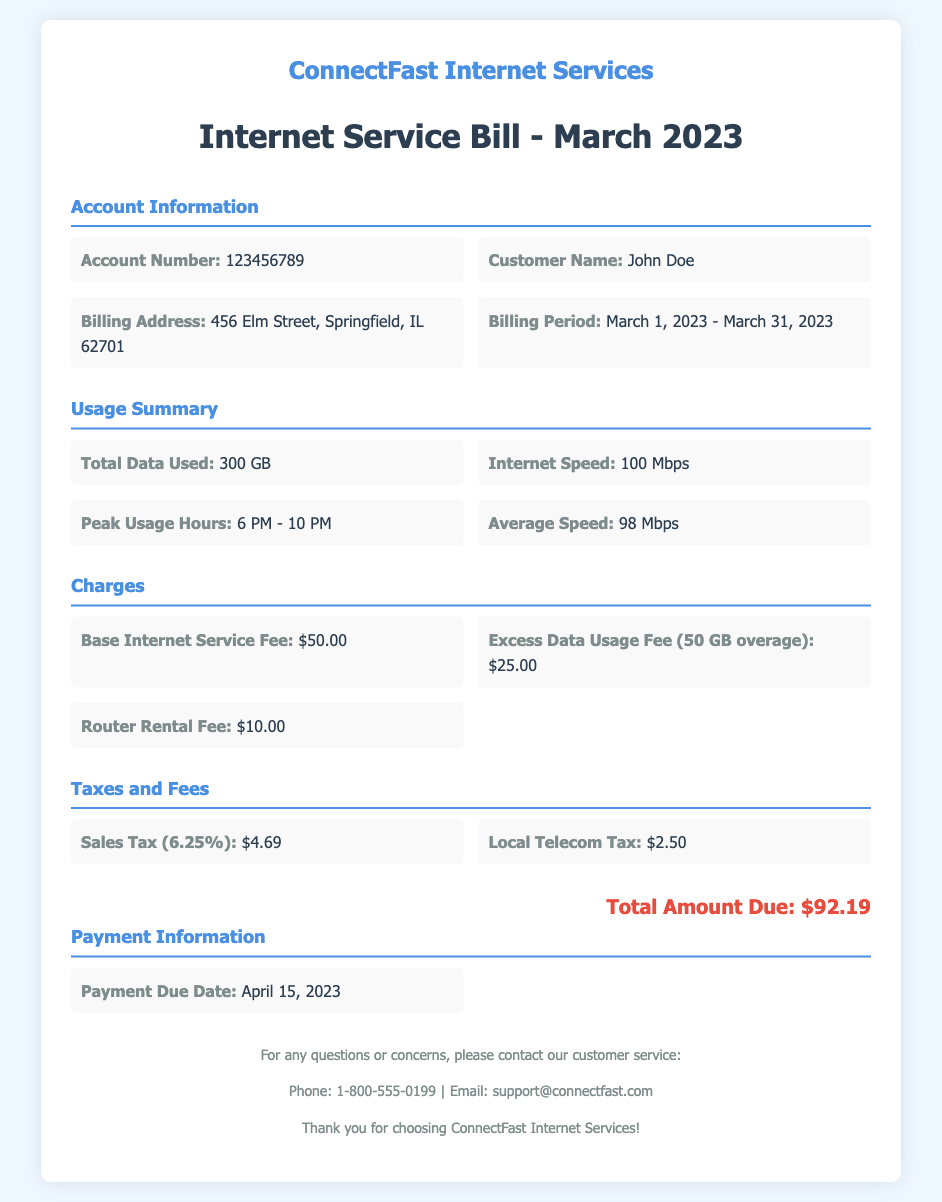What is the account number? The account number is specifically stated in the account information section of the document.
Answer: 123456789 Who is the customer? The customer's name is mentioned directly in the account information section.
Answer: John Doe What is the billing address? The billing address is provided under the account information section of the document.
Answer: 456 Elm Street, Springfield, IL 62701 What was the total data used? The document lists the total data used in the usage summary section.
Answer: 300 GB What is the base internet service fee? The base internet service fee is detailed in the charges section of the document.
Answer: $50.00 What is the payment due date? The payment due date is explicitly mentioned in the payment information section.
Answer: April 15, 2023 How much is the excess data usage fee? The excess data usage fee is included in the charges section and is a specific fee stated.
Answer: $25.00 What is the total amount due? The total amount due is calculated based on all charges and taxes outlined in the document.
Answer: $92.19 What time are peak usage hours? The peak usage hours are specified in the usage summary section of the document.
Answer: 6 PM - 10 PM 